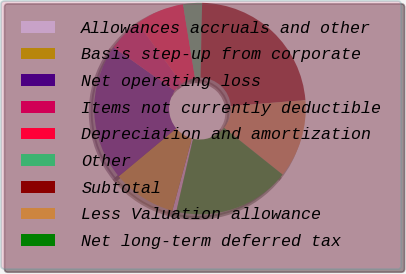Convert chart. <chart><loc_0><loc_0><loc_500><loc_500><pie_chart><fcel>Allowances accruals and other<fcel>Basis step-up from corporate<fcel>Net operating loss<fcel>Items not currently deductible<fcel>Depreciation and amortization<fcel>Other<fcel>Subtotal<fcel>Less Valuation allowance<fcel>Net long-term deferred tax<nl><fcel>0.61%<fcel>9.73%<fcel>20.87%<fcel>5.17%<fcel>7.45%<fcel>2.89%<fcel>23.4%<fcel>12.01%<fcel>17.87%<nl></chart> 